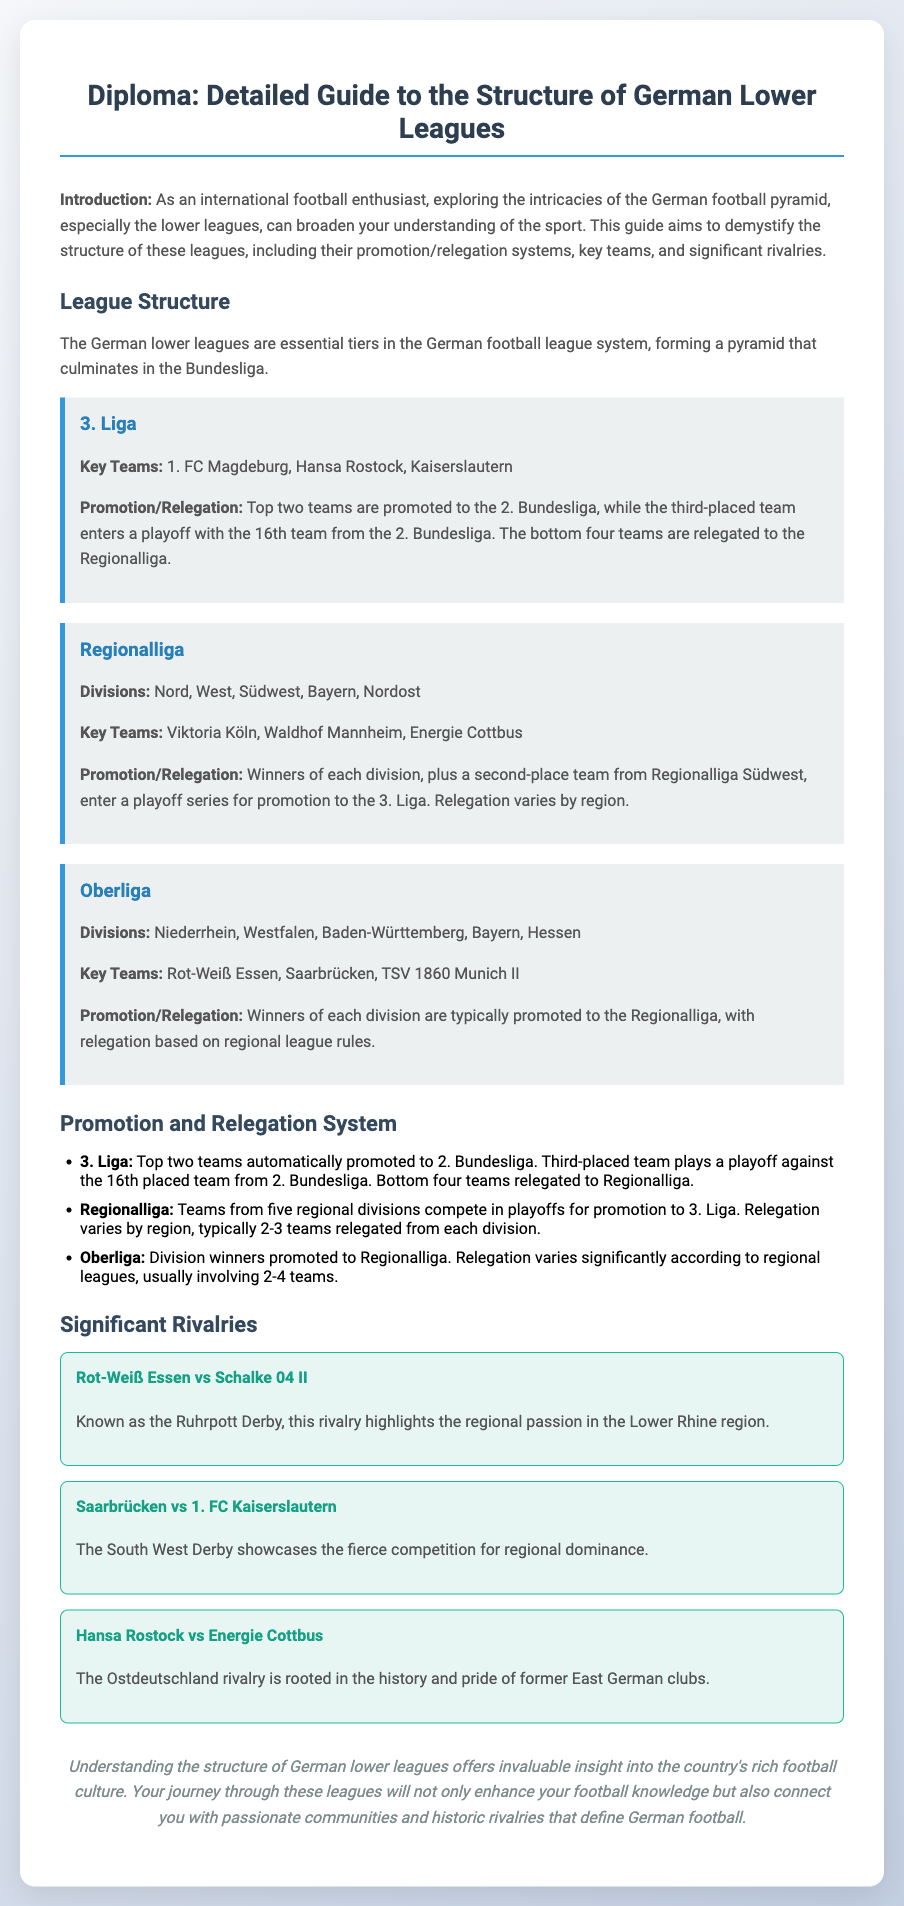what is the top tier of the German football league system? The document explains that the structure of German lower leagues culminates in the Bundesliga, which is the top tier.
Answer: Bundesliga how many teams are automatically promoted from the 3. Liga? The document states that the top two teams are automatically promoted to the 2. Bundesliga.
Answer: Two what is the name of the rivalry between Rot-Weiß Essen and Schalke 04 II? It is referred to as the Ruhrpott Derby in the document.
Answer: Ruhrpott Derby which team is mentioned as a key team in the Oberliga? The document highlights Rot-Weiß Essen as one of the key teams in the Oberliga.
Answer: Rot-Weiß Essen how many divisions does the Regionalliga have? The document lists five divisions within the Regionalliga.
Answer: Five what is the name of the derby showcasing the competition between Saarbrücken and 1. FC Kaiserslautern? The document refers to it as the South West Derby.
Answer: South West Derby what teams compete in a playoff for promotion from the Regionalliga? The winners of each division, plus a second-place team from Regionalliga Südwest, enter a playoff for promotion to the 3. Liga.
Answer: Winners of each division plus a second-place team how many teams are typically relegated from each Oberliga division? The document mentions that the number varies significantly according to regional leagues, usually involving 2-4 teams.
Answer: 2-4 teams what is the focus of this diploma document? The document aims to provide a detailed guide to the structure of the German lower leagues, including promotion/relegation systems, key teams, and rivalries.
Answer: Structure of German lower leagues 